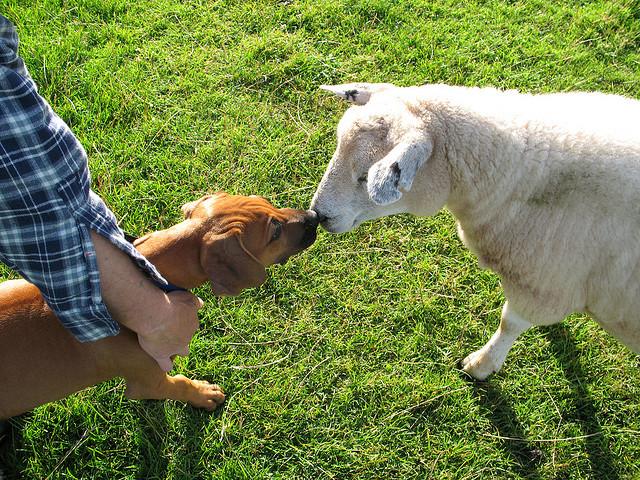What pattern is the person's shirt?
Short answer required. Plaid. Are the animal's noses touching?
Concise answer only. Yes. Are the animals both the same species?
Give a very brief answer. No. 